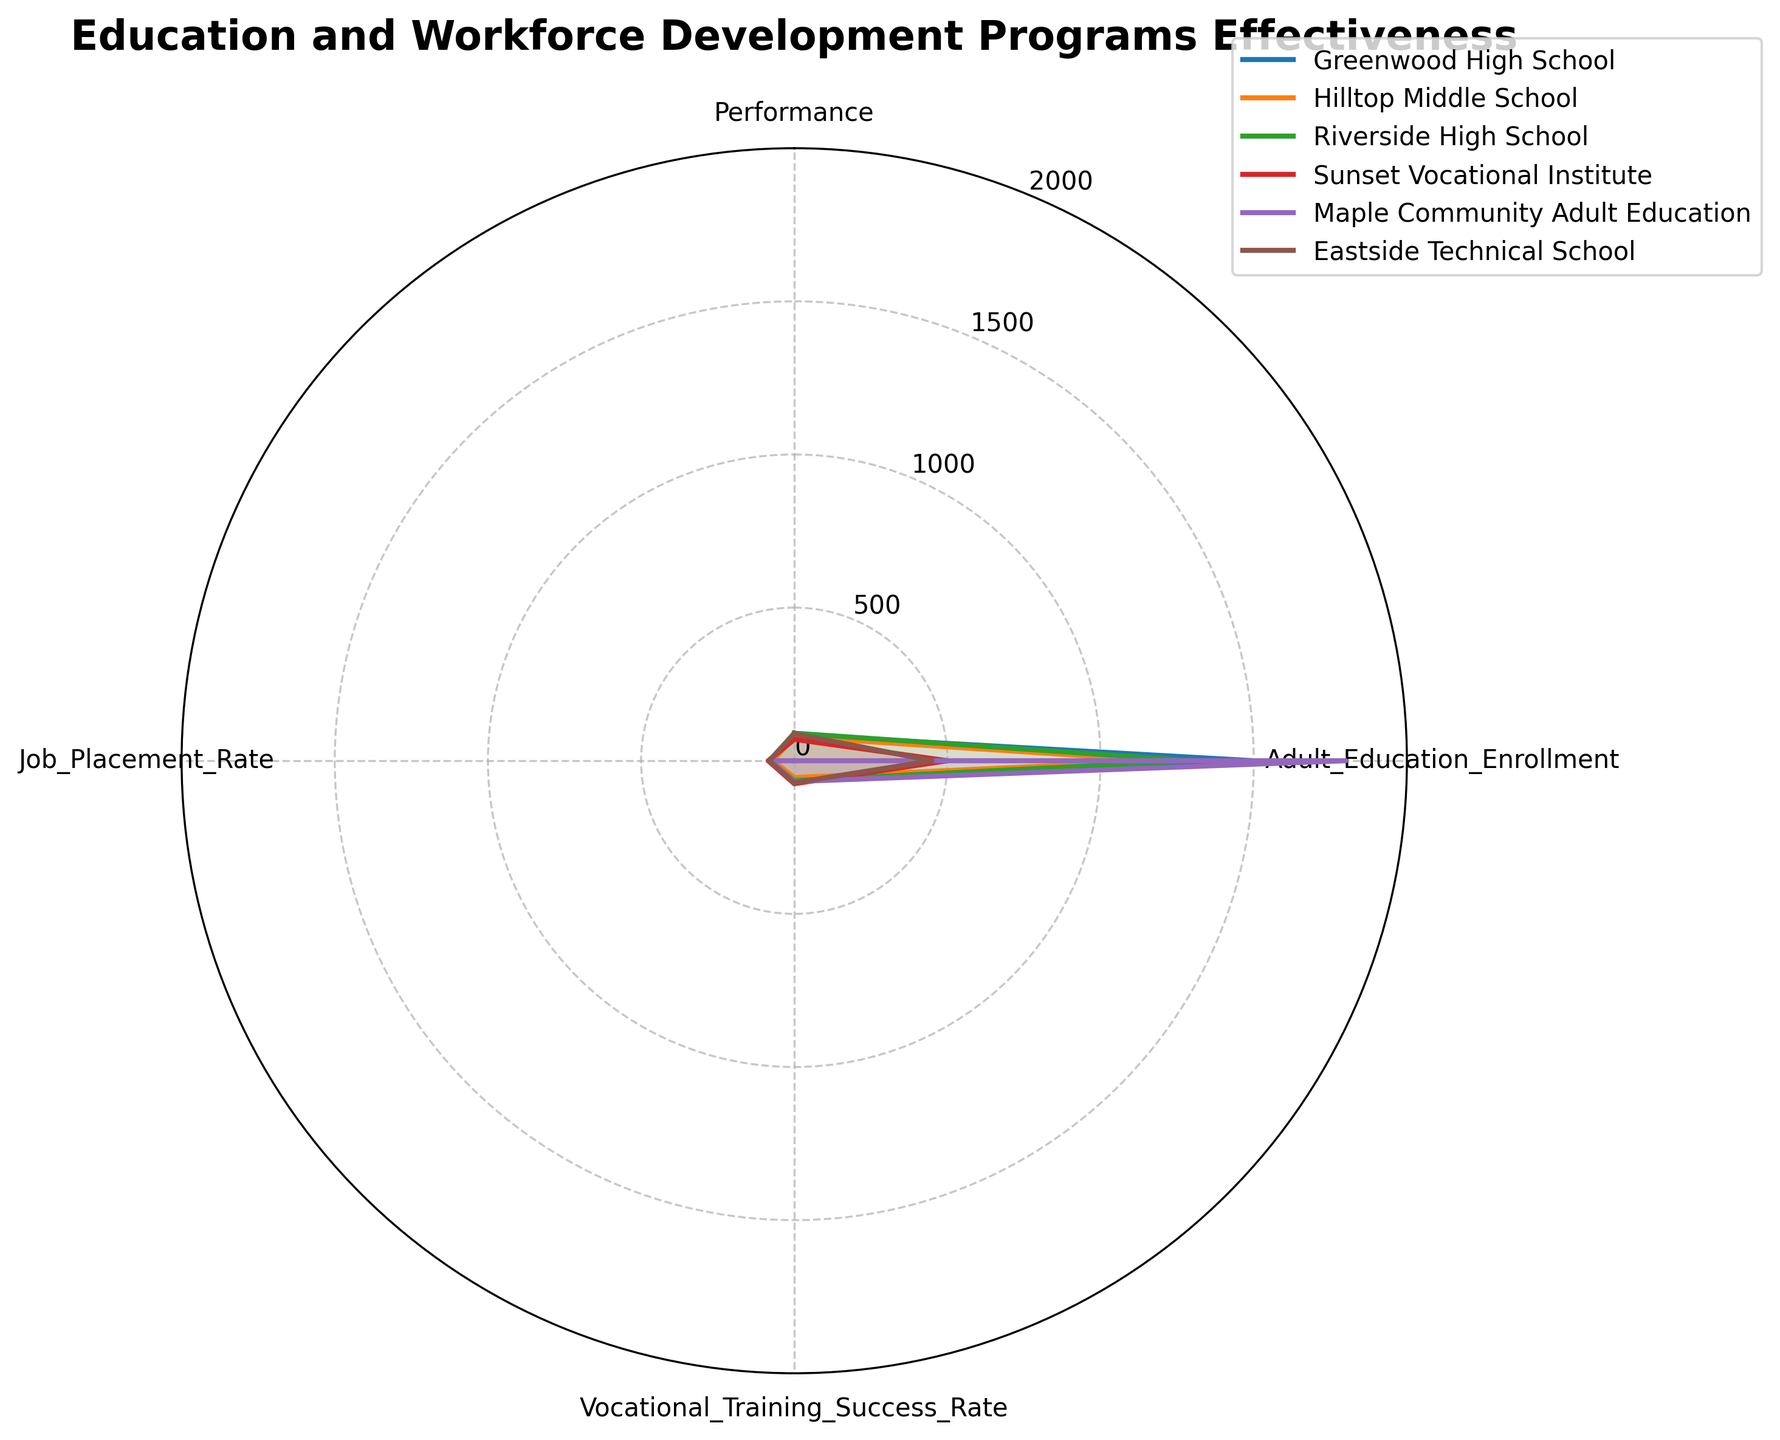What are the categories depicted in the radar chart? The categories are the labeled data points around the circular radar chart. From the chart, these categories are 'Performance', 'Adult_Education_Enrollment', 'Vocational_Training_Success_Rate', and 'Job_Placement_Rate'.
Answer: 'Performance', 'Adult_Education_Enrollment', 'Vocational_Training_Success_Rate', 'Job_Placement_Rate' Which school has the highest 'Performance' rate? To find the highest 'Performance' rate, compare the 'Performance' scores of all schools. Greenwood High School has a 'Performance' score of 85, Hilltop Middle School has 78, Riverside High School has 90, Sunset Vocational Institute has 70, and Eastside Technical School has 88. Riverside High School has the highest at 90.
Answer: Riverside High School Which institution has the highest job placement rate? Compare the 'Job_Placement_Rate' of all institutions on the chart. Greenwood High School has 75, Hilltop Middle School has 70, Riverside High School has 80, Sunset Vocational Institute has 85, and Eastside Technical School has 82. Sunset Vocational Institute has the highest job placement rate at 85.
Answer: Sunset Vocational Institute What is the average 'Vocational Training Success Rate' of all institutions? Calculate the average by summing the 'Vocational_Training_Success_Rate' values and dividing by the number of institutions. Scores are Greenwod High (60), Hilltop Middle (55), Riverside High (65), Sunset Vocational (75), Maple Education (68), Eastside Technical (72). Total is 395/6 = 65.83.
Answer: 65.83 How do adult education enrollments compare between Maple Community Adult Education and Sunset Vocational Institute? Examine the 'Adult_Education_Enrollment' values. Maple Community Adult Education has an enrollment of 1800, and Sunset Vocational Institute has 500. Comparison shows Maple Community Adult Education has a significantly higher enrollment.
Answer: Maple Community Adult Education has a higher enrollment Is there a school with no data for 'Performance'? Check the 'Performance' value for all institutions. All institutions except Maple Community Adult Education have 'Performance' data; Maple Community Adult Education has 'NA'.
Answer: Maple Community Adult Education Which school has the lowest vocational training success rate? Compare 'Vocational_Training_Success_Rate' values: Greenwood High (60), Hilltop Middle (55), Riverside High (65), Sunset Vocational (75), Maple Education (68), Eastside Technical (72). Hilltop Middle has the lowest rate at 55.
Answer: Hilltop Middle School How many institutions have a job placement rate above 80? Count the institutions with 'Job_Placement_Rate' greater than 80. Riverside High (80), Sunset Vocational (85), Eastside Technical (82). Three institutions meet this criterion.
Answer: Three institutions What pattern do you observe for the Sunset Vocational Institute's ratings? Break down Sunset Vocational's scores: 'Performance' (70), 'Adult_Education_Enrollment' (500), 'Vocational_Training_Success_Rate' (75), 'Job_Placement_Rate' (85). The pattern shows relatively low 'Performance' and 'Adult Education Enrollment' scores but high success and job placement rates.
Answer: Low 'Performance' and 'Adult Education Enrollment', high 'Vocational Training Success Rate' and 'Job Placement Rate' 